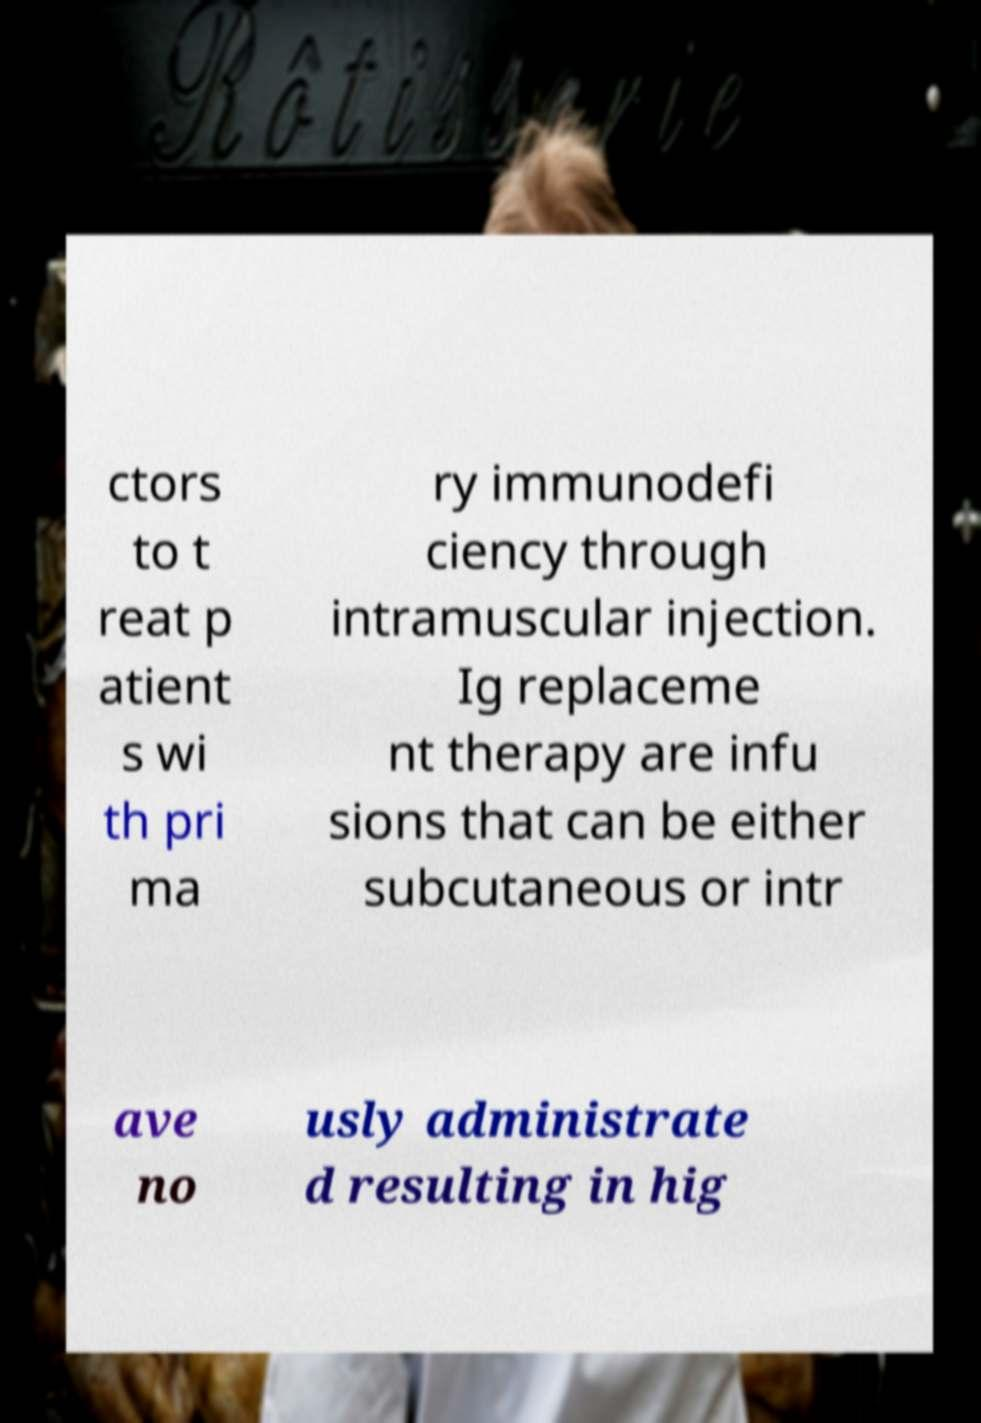Please read and relay the text visible in this image. What does it say? ctors to t reat p atient s wi th pri ma ry immunodefi ciency through intramuscular injection. Ig replaceme nt therapy are infu sions that can be either subcutaneous or intr ave no usly administrate d resulting in hig 